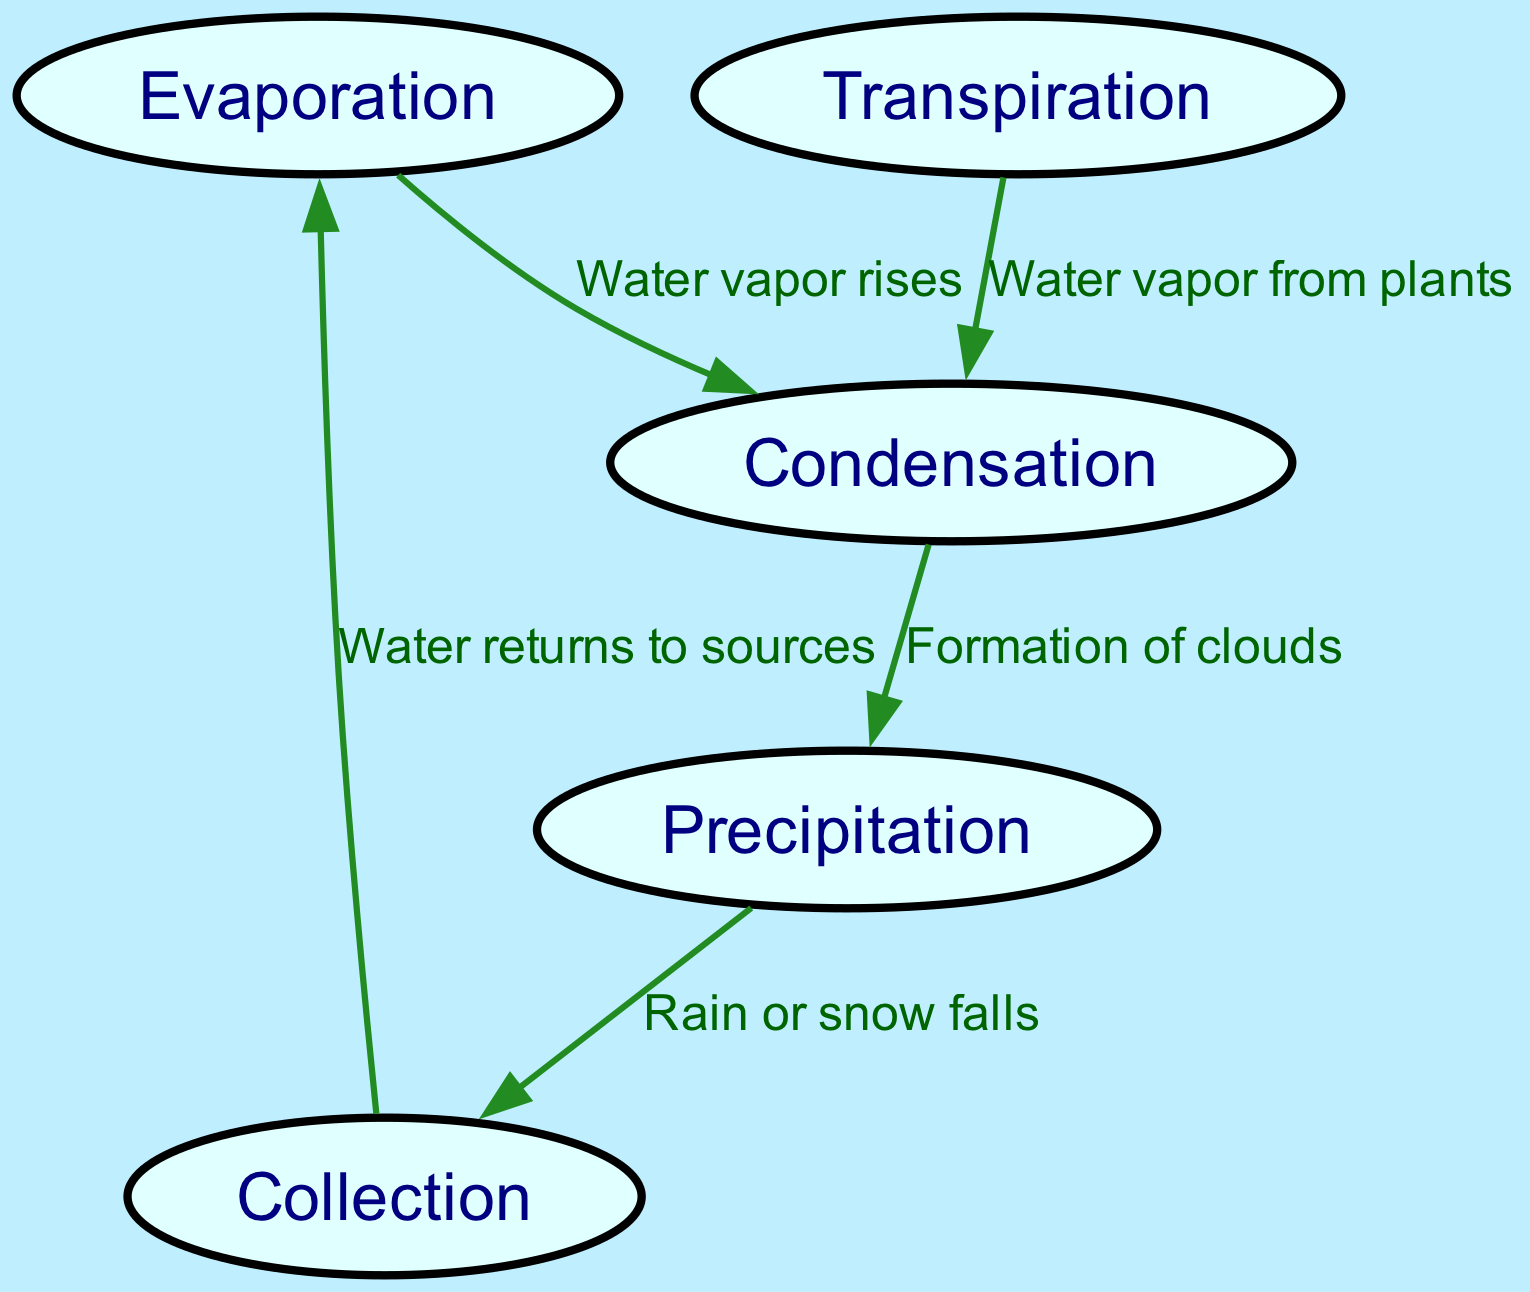What are the stages of the water cycle displayed in the diagram? The diagram includes five nodes representing the stages: Evaporation, Transpiration, Condensation, Precipitation, and Collection. Therefore, the answer lists all these stages.
Answer: Evaporation, Transpiration, Condensation, Precipitation, Collection How many nodes are present in the diagram? The diagram has five nodes: Evaporation, Transpiration, Condensation, Precipitation, and Collection; hence the total count is determined by simply counting these nodes.
Answer: 5 What is the relationship between Evaporation and Condensation? The edge connects Evaporation to Condensation with the label "Water vapor rises," indicating that this is the process through which water vapor moves from evaporation to condensation.
Answer: Water vapor rises Which stage follows Condensation in the water cycle? Observing the edges in the diagram, the next stage after Condensation is connected to Precipitation, indicating a sequential flow.
Answer: Precipitation What happens after Precipitation? According to the diagram, Precipitation leads to Collection through the edge labeled "Rain or snow falls." Therefore, the process that occurs after Precipitation is indicated directly by this connection.
Answer: Collection How does Collection relate back to Evaporation? The diagram shows that Collection is connected back to Evaporation with the label "Water returns to sources," indicating a cyclical movement. Thus, this relationship establishes a connection back to the starting point of the cycle.
Answer: Water returns to sources Which two stages contribute water vapor to the process of Condensation? The two stages providing water vapor to Condensation are Evaporation (with "Water vapor rises") and Transpiration (with "Water vapor from plants"). Multiple connections to Condensation indicate both sources of vapor contributing to its formation.
Answer: Evaporation and Transpiration What type of edge connects Condensation to Precipitation? The edge between these two nodes is labeled "Formation of clouds," which describes the process that leads to Precipitation. This gives the edge a descriptive purpose regarding what happens as a result of Condensation.
Answer: Formation of clouds 